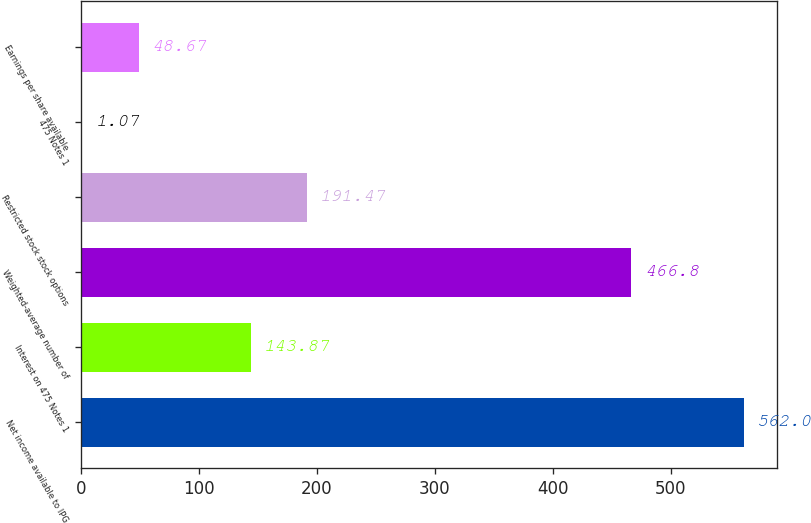<chart> <loc_0><loc_0><loc_500><loc_500><bar_chart><fcel>Net income available to IPG<fcel>Interest on 475 Notes 1<fcel>Weighted-average number of<fcel>Restricted stock stock options<fcel>475 Notes 1<fcel>Earnings per share available<nl><fcel>562<fcel>143.87<fcel>466.8<fcel>191.47<fcel>1.07<fcel>48.67<nl></chart> 